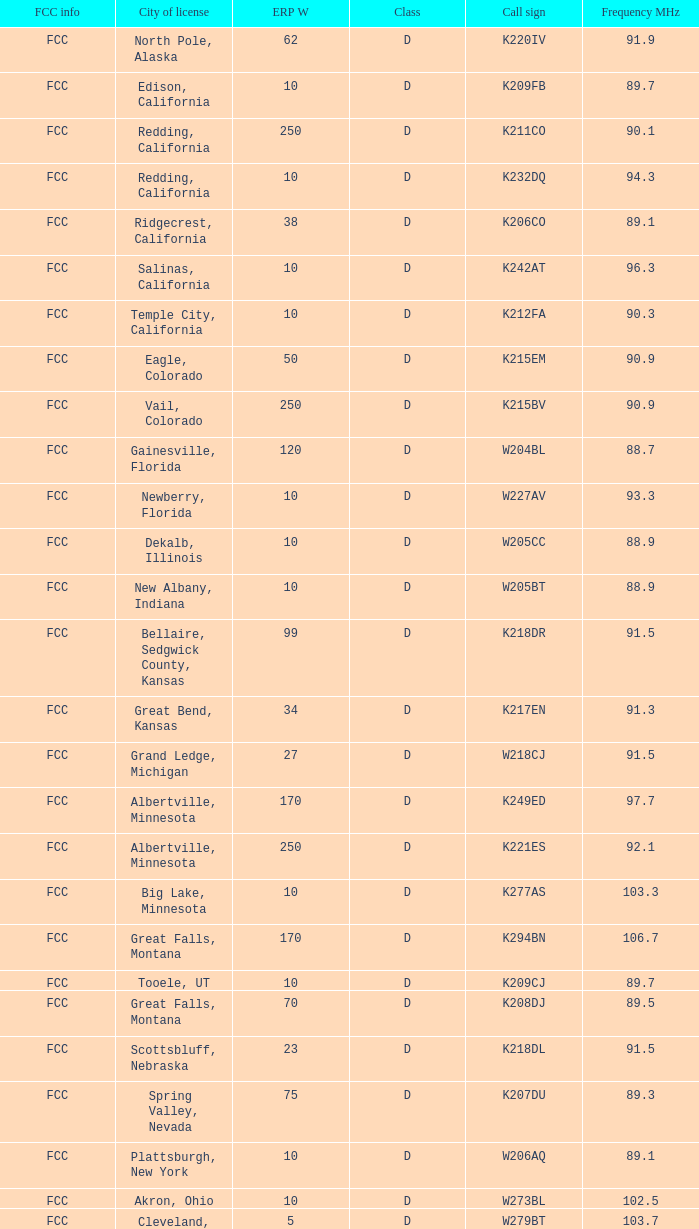What is the call sign of the translator in Spring Valley, Nevada? K207DU. 